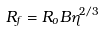Convert formula to latex. <formula><loc_0><loc_0><loc_500><loc_500>R _ { f } = R _ { o } B \eta ^ { 2 / 3 }</formula> 